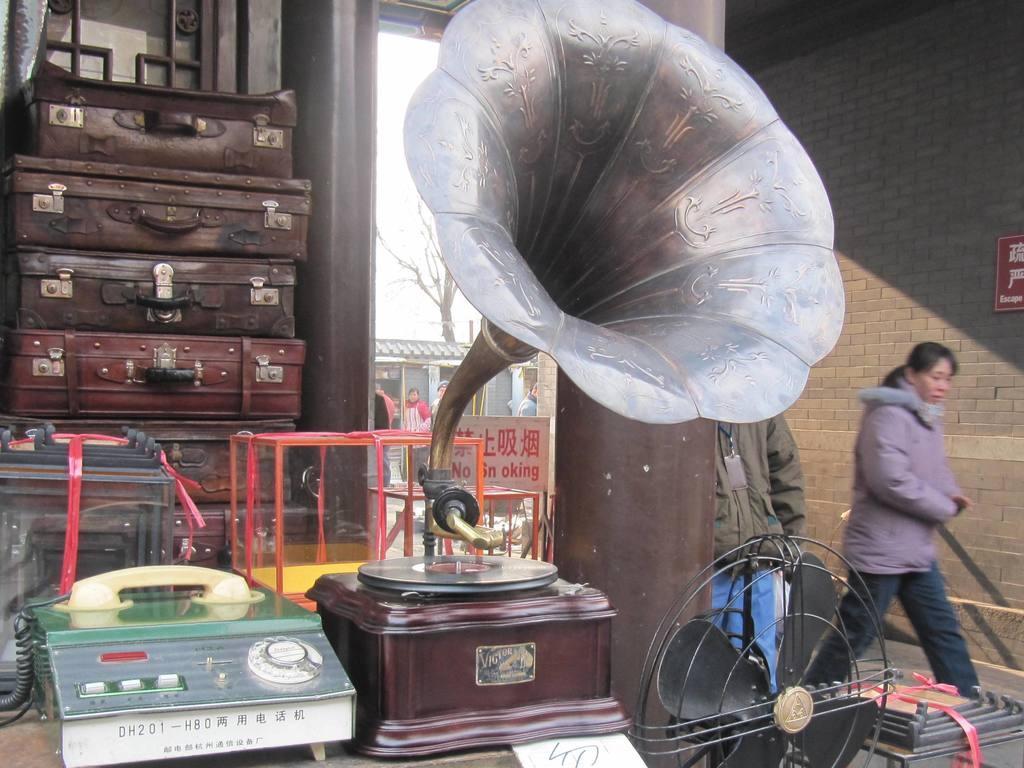Describe this image in one or two sentences. Here in this picture, in the front we can see a gramophone and a telephone present on a table and behind that we can see some suitcases present and we can also see a railing and a sign board present and beside that we can see a table fan present and we can also see other people standing and walking over there and outside that we can see other store and a tree present. 